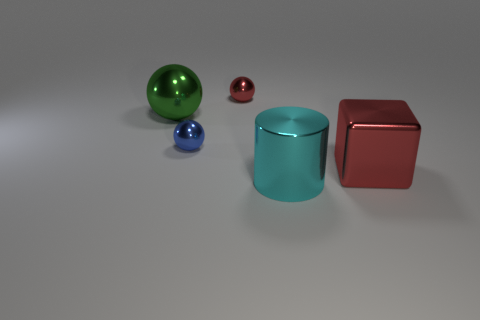There is a metallic object that is both on the left side of the big cyan object and in front of the large metal sphere; what is its shape?
Make the answer very short. Sphere. Are there any big blocks to the right of the green metallic ball?
Offer a very short reply. Yes. How many things are either large blue shiny balls or tiny balls that are behind the green sphere?
Make the answer very short. 1. What color is the big shiny object to the left of the small object that is behind the large green shiny sphere?
Your answer should be very brief. Green. What number of other things are there of the same material as the large green sphere
Your response must be concise. 4. What number of metallic things are cylinders or cubes?
Make the answer very short. 2. There is a big metal thing that is the same shape as the tiny red object; what color is it?
Your response must be concise. Green. What number of things are either big red objects or yellow metallic cylinders?
Offer a very short reply. 1. What is the shape of the cyan object that is the same material as the cube?
Keep it short and to the point. Cylinder. What number of big things are either shiny balls or cyan objects?
Ensure brevity in your answer.  2. 